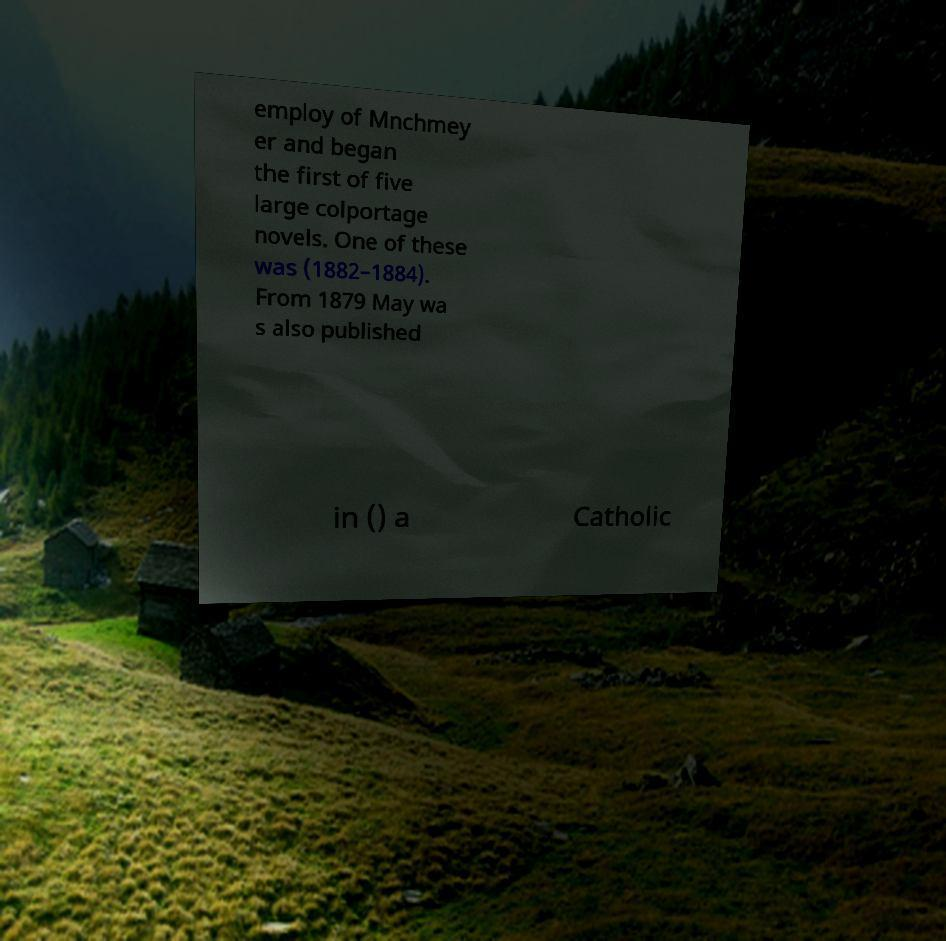What messages or text are displayed in this image? I need them in a readable, typed format. employ of Mnchmey er and began the first of five large colportage novels. One of these was (1882–1884). From 1879 May wa s also published in () a Catholic 